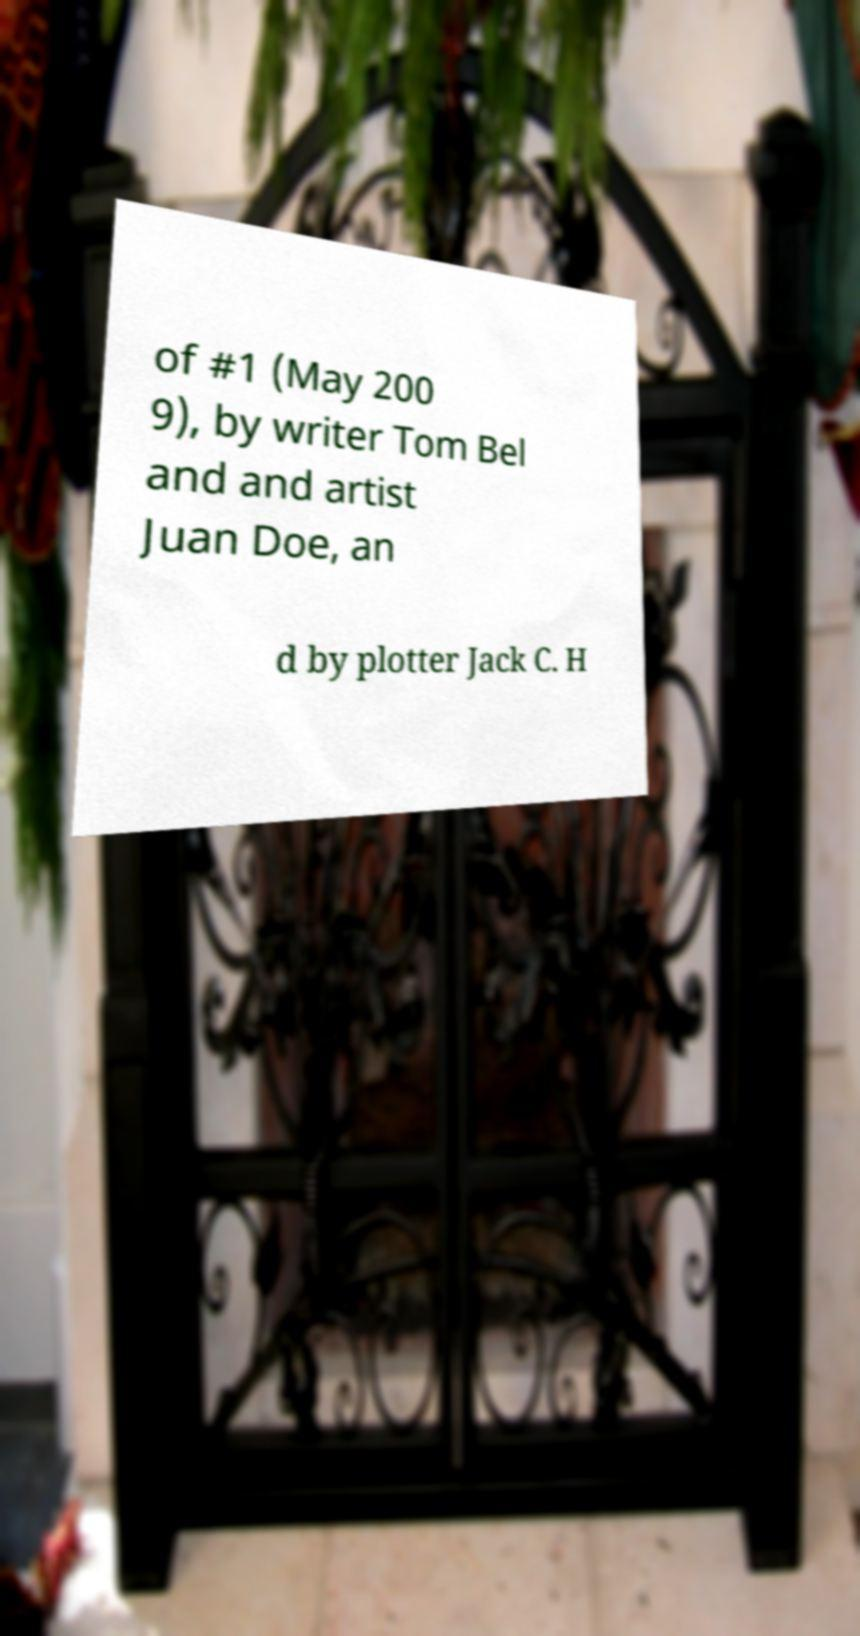I need the written content from this picture converted into text. Can you do that? of #1 (May 200 9), by writer Tom Bel and and artist Juan Doe, an d by plotter Jack C. H 